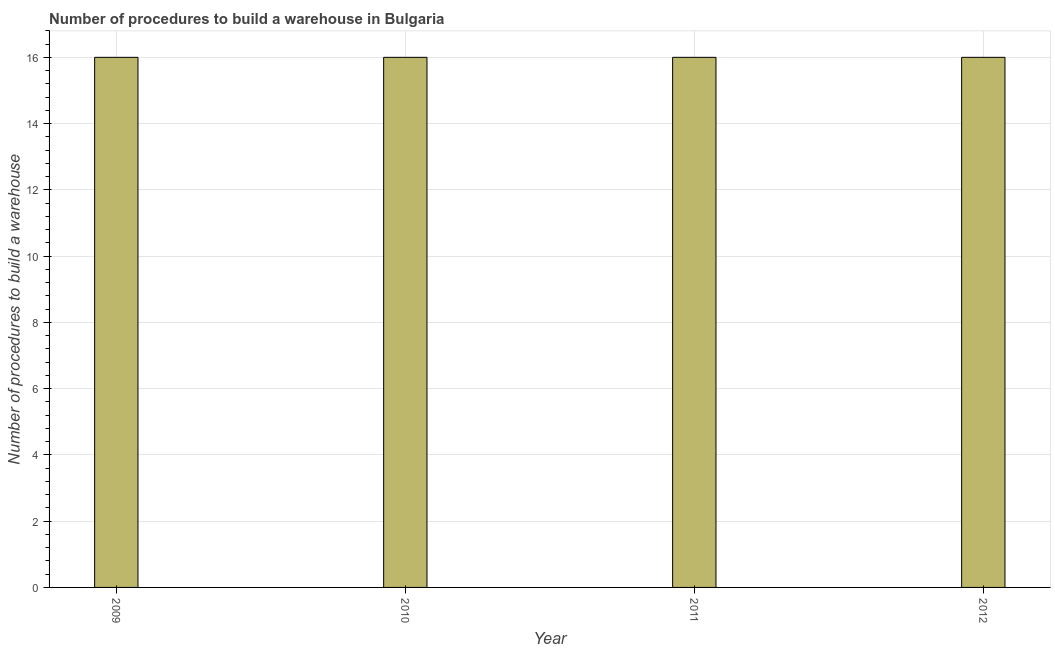Does the graph contain grids?
Your response must be concise. Yes. What is the title of the graph?
Make the answer very short. Number of procedures to build a warehouse in Bulgaria. What is the label or title of the X-axis?
Your answer should be very brief. Year. What is the label or title of the Y-axis?
Offer a terse response. Number of procedures to build a warehouse. In which year was the number of procedures to build a warehouse minimum?
Make the answer very short. 2009. What is the sum of the number of procedures to build a warehouse?
Provide a short and direct response. 64. What is the difference between the number of procedures to build a warehouse in 2009 and 2011?
Your answer should be compact. 0. Is the difference between the number of procedures to build a warehouse in 2009 and 2012 greater than the difference between any two years?
Provide a succinct answer. Yes. What is the difference between the highest and the second highest number of procedures to build a warehouse?
Provide a succinct answer. 0. Is the sum of the number of procedures to build a warehouse in 2011 and 2012 greater than the maximum number of procedures to build a warehouse across all years?
Keep it short and to the point. Yes. What is the difference between the highest and the lowest number of procedures to build a warehouse?
Keep it short and to the point. 0. How many bars are there?
Provide a short and direct response. 4. Are all the bars in the graph horizontal?
Make the answer very short. No. What is the difference between two consecutive major ticks on the Y-axis?
Provide a short and direct response. 2. What is the Number of procedures to build a warehouse in 2011?
Offer a terse response. 16. What is the Number of procedures to build a warehouse in 2012?
Give a very brief answer. 16. What is the difference between the Number of procedures to build a warehouse in 2009 and 2010?
Your answer should be very brief. 0. What is the difference between the Number of procedures to build a warehouse in 2009 and 2011?
Keep it short and to the point. 0. What is the difference between the Number of procedures to build a warehouse in 2009 and 2012?
Provide a succinct answer. 0. What is the difference between the Number of procedures to build a warehouse in 2010 and 2012?
Your answer should be very brief. 0. What is the ratio of the Number of procedures to build a warehouse in 2009 to that in 2011?
Provide a short and direct response. 1. What is the ratio of the Number of procedures to build a warehouse in 2009 to that in 2012?
Offer a very short reply. 1. 